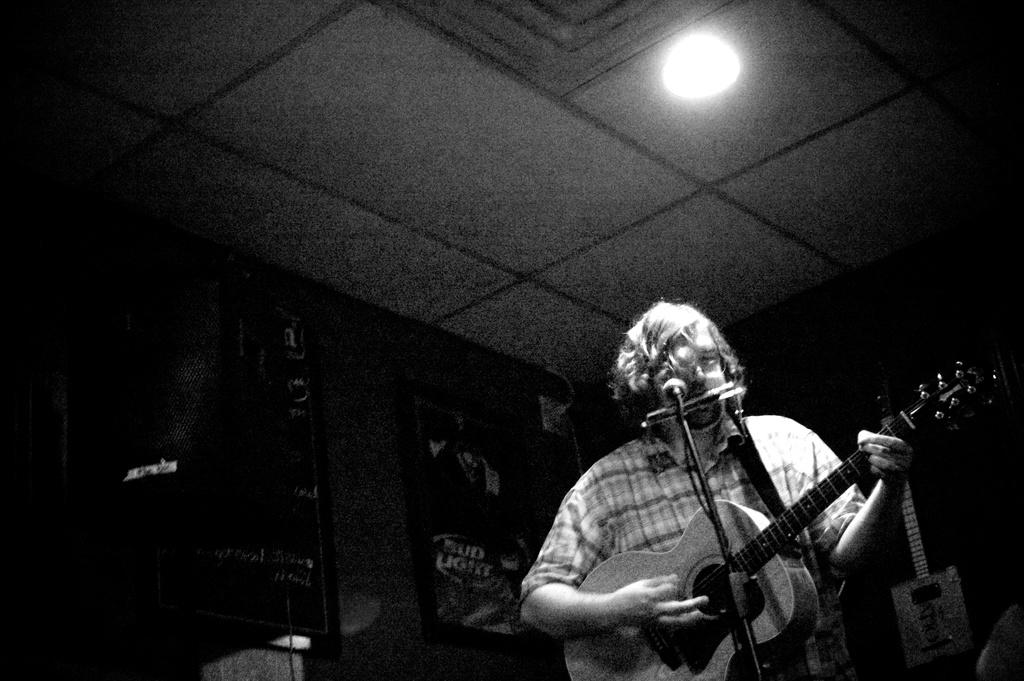What is the person in the image doing? The person is playing a guitar. What is the person wearing in the image? The person is wearing a white shirt. What object is in front of the person? There is a microphone in front of the person. What type of structure is visible in the image? There is a roof visible in the image. What can be seen providing illumination in the image? There is a light visible in the image. What verse is the person reciting into the microphone in the image? There is no indication in the image that the person is reciting a verse or any spoken content. What type of destruction is visible in the image? There is no destruction present in the image; it features a person playing a guitar with a microphone and a light. 